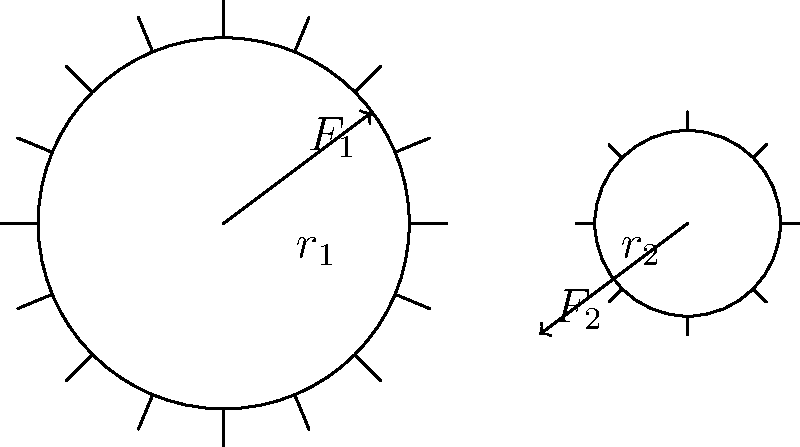In the simple gear system shown above, gear 1 (larger) has a radius $r_1$ and experiences a force $F_1$, while gear 2 (smaller) has a radius $r_2$ and experiences a force $F_2$. If the system is in equilibrium, what is the relationship between $F_1$ and $F_2$? Express your answer in terms of $r_1$ and $r_2$. To solve this problem, we need to consider the concept of torque and the principle of equilibrium in a gear system. Let's follow these steps:

1. Recall that torque $\tau$ is the product of force $F$ and the perpendicular distance $r$ from the axis of rotation: $\tau = F \cdot r$

2. For the system to be in equilibrium, the torques on both gears must be equal and opposite:
   $\tau_1 = -\tau_2$

3. Express the torques for each gear:
   Gear 1: $\tau_1 = F_1 \cdot r_1$
   Gear 2: $\tau_2 = F_2 \cdot r_2$

4. Set up the equilibrium equation:
   $F_1 \cdot r_1 = F_2 \cdot r_2$

5. Rearrange the equation to express $F_1$ in terms of $F_2$:
   $F_1 = F_2 \cdot \frac{r_2}{r_1}$

This relationship shows that the forces are inversely proportional to the radii of the gears. The smaller gear (with radius $r_2$) will experience a larger force than the larger gear (with radius $r_1$) when the system is in equilibrium.

This concept is crucial in understanding how gears transmit force and motion in mechanical systems, which has applications in various fields, including psychology, where mechanical principles might be applied to study human motor skills or design ergonomic tools.
Answer: $F_1 = F_2 \cdot \frac{r_2}{r_1}$ 